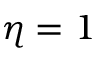<formula> <loc_0><loc_0><loc_500><loc_500>\eta = 1</formula> 